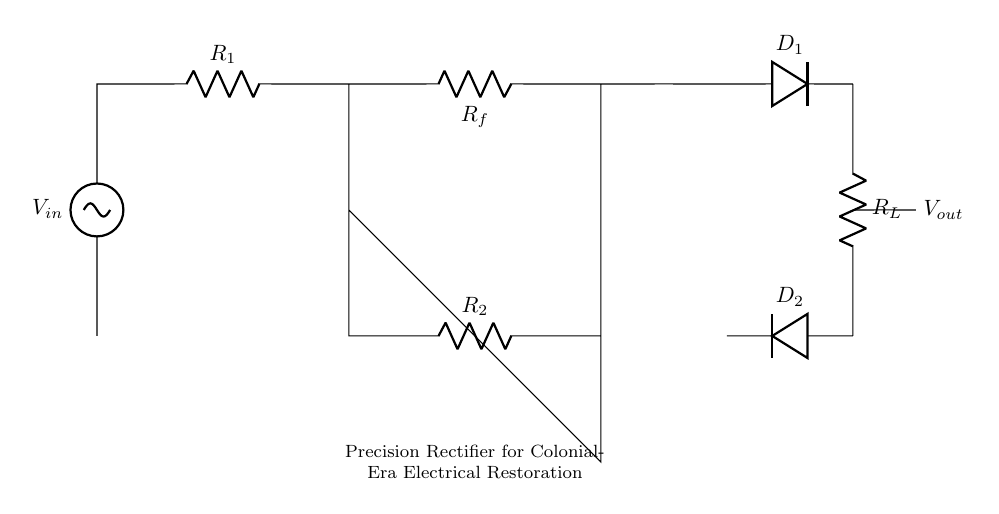What is the function of the op-amp in this circuit? The op-amp in this precision rectifier circuit serves as a buffer and amplification stage, ensuring that the output can accurately reflect the input voltage without significant loss. It helps to minimize the input impedance and maximize the output accuracy.
Answer: buffer and amplification What type of diodes are used in this circuit? The circuit uses standard diodes, as indicated by the notation. They allow current to pass in one direction while blocking it in the reverse direction, which is essential for rectification.
Answer: standard Which component provides the load resistance for the output? The component labeled R_L is positioned in the circuit as the load resistor, which determines the load that the output voltage is connected to during its operation.
Answer: R_L What is the role of the resistors R1 and R2? Resistors R1 and R2 function as part of the feedback mechanism and the input stage of the op-amp, helping to set the gain of the op-amp and stabilize the overall circuit performance while maintaining accuracy in the rectification process.
Answer: feedback mechanism and input stage How many diodes are present in the rectifier circuit? There are two diodes in the circuit labeled D1 and D2. Their configuration prevents reverse polarity and allows for the rectification of both halves of the input signal.
Answer: two What happens to the output voltage during negative input voltage cycles? During negative input cycles, the first diode D1 is forward-biased while D2 is reverse-biased, thus allowing current to flow only in one direction, effectively producing a positive output voltage. This is crucial for accurate measurement in restoration projects.
Answer: positive output voltage 